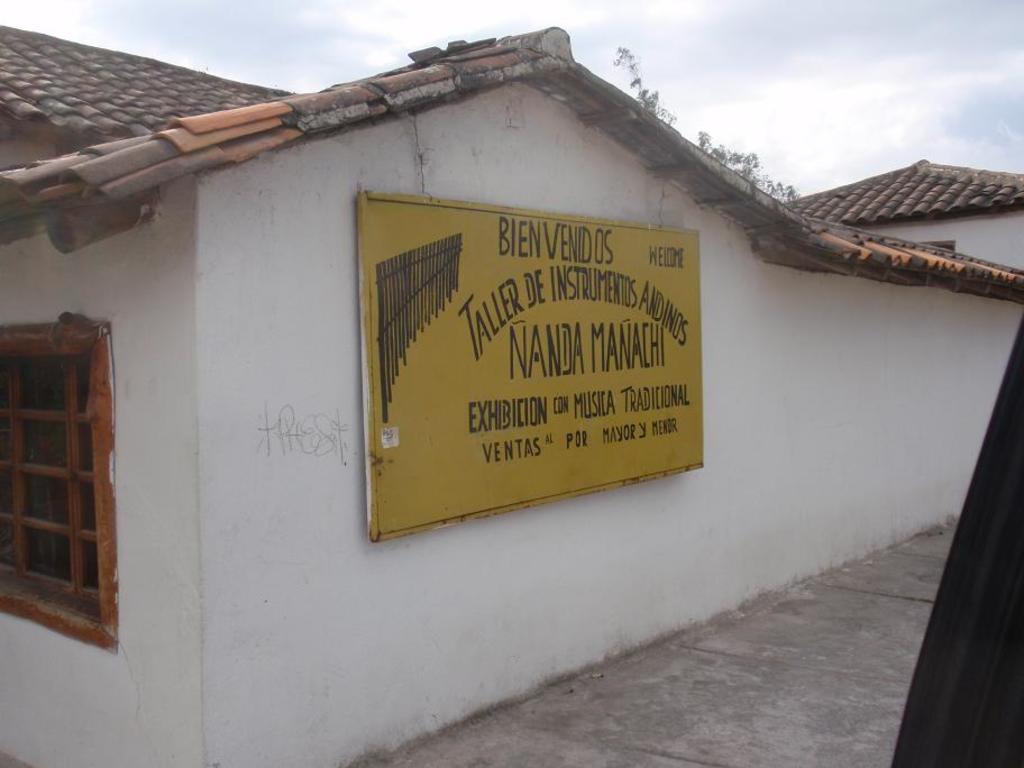What is the name on the building?
Make the answer very short. Nanda manachi. 